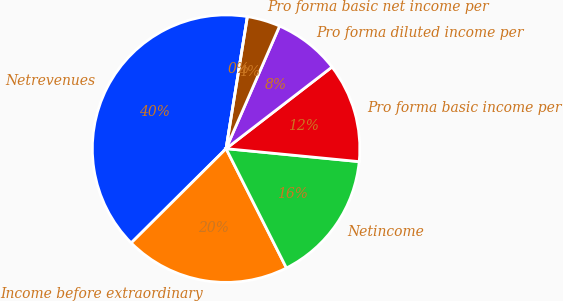<chart> <loc_0><loc_0><loc_500><loc_500><pie_chart><fcel>Netrevenues<fcel>Income before extraordinary<fcel>Netincome<fcel>Pro forma basic income per<fcel>Pro forma diluted income per<fcel>Pro forma basic net income per<fcel>Unnamed: 6<nl><fcel>40.0%<fcel>20.0%<fcel>16.0%<fcel>12.0%<fcel>8.0%<fcel>4.0%<fcel>0.0%<nl></chart> 